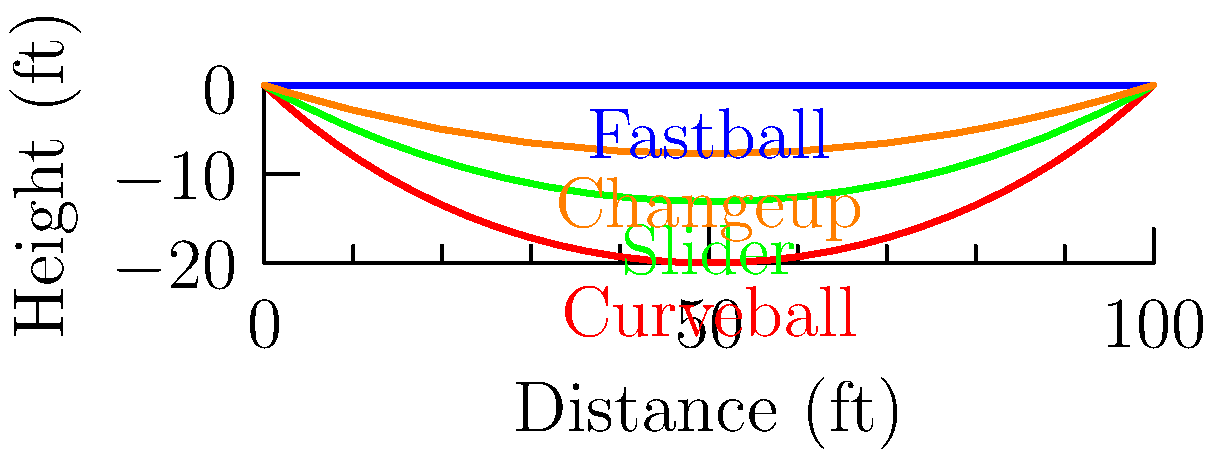As a physical education teacher encouraging students to join the baseball team, you're explaining different pitch types. Based on the trajectories shown in the graph, which pitch would be most effective for deceiving a batter expecting a fastball? To determine which pitch would be most effective for deceiving a batter expecting a fastball, we need to analyze the trajectories of each pitch type:

1. Fastball: Straight line trajectory, no vertical movement.
2. Curveball: Significant downward break, starting high and ending low.
3. Slider: Moderate downward and lateral movement, breaking later than the curveball.
4. Changeup: Slight downward movement, similar to the fastball but slower.

Step-by-step analysis:
1. The fastball is the baseline pitch the batter is expecting.
2. The curveball has the most dramatic movement, but it's easily distinguishable from the fastball early in its trajectory.
3. The changeup has a similar trajectory to the fastball but moves slower, which can throw off the batter's timing.
4. The slider maintains a trajectory similar to the fastball for the longest distance before breaking late.

The slider would be most effective for deceiving a batter expecting a fastball because:
a) It looks like a fastball for the majority of its trajectory.
b) The late break makes it difficult for the batter to adjust in time.
c) The combination of downward and lateral movement is challenging to read.
Answer: Slider 